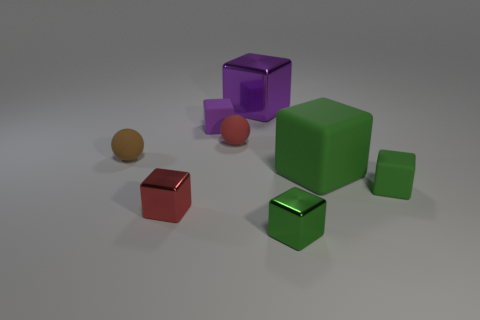How many green cubes must be subtracted to get 2 green cubes? 1 Subtract 1 blocks. How many blocks are left? 5 Subtract all purple cylinders. How many green cubes are left? 3 Subtract all red cubes. How many cubes are left? 5 Subtract all green rubber blocks. How many blocks are left? 4 Subtract all red cubes. Subtract all purple spheres. How many cubes are left? 5 Add 2 big red cubes. How many objects exist? 10 Subtract all blocks. How many objects are left? 2 Subtract all green metal blocks. Subtract all big purple metal cubes. How many objects are left? 6 Add 8 large purple shiny objects. How many large purple shiny objects are left? 9 